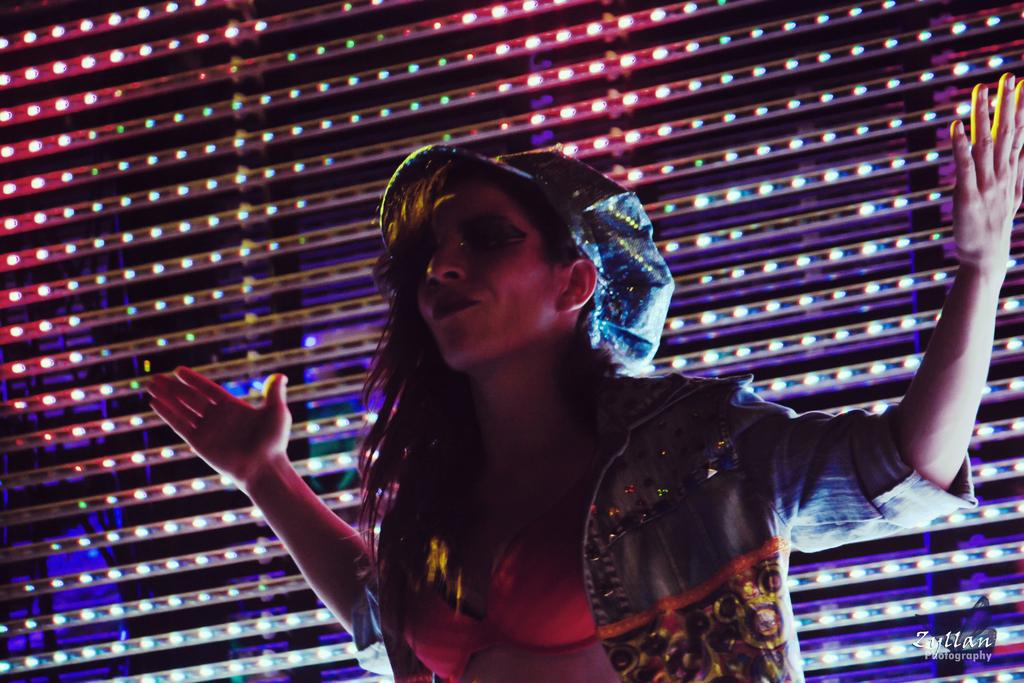Who is the main subject in the image? There is a woman standing in the center of the image. What can be seen in the background of the image? There is a wall and lights visible in the background of the image. What type of quilt is being used to cover the authority figure in the image? There is no authority figure or quilt present in the image. 